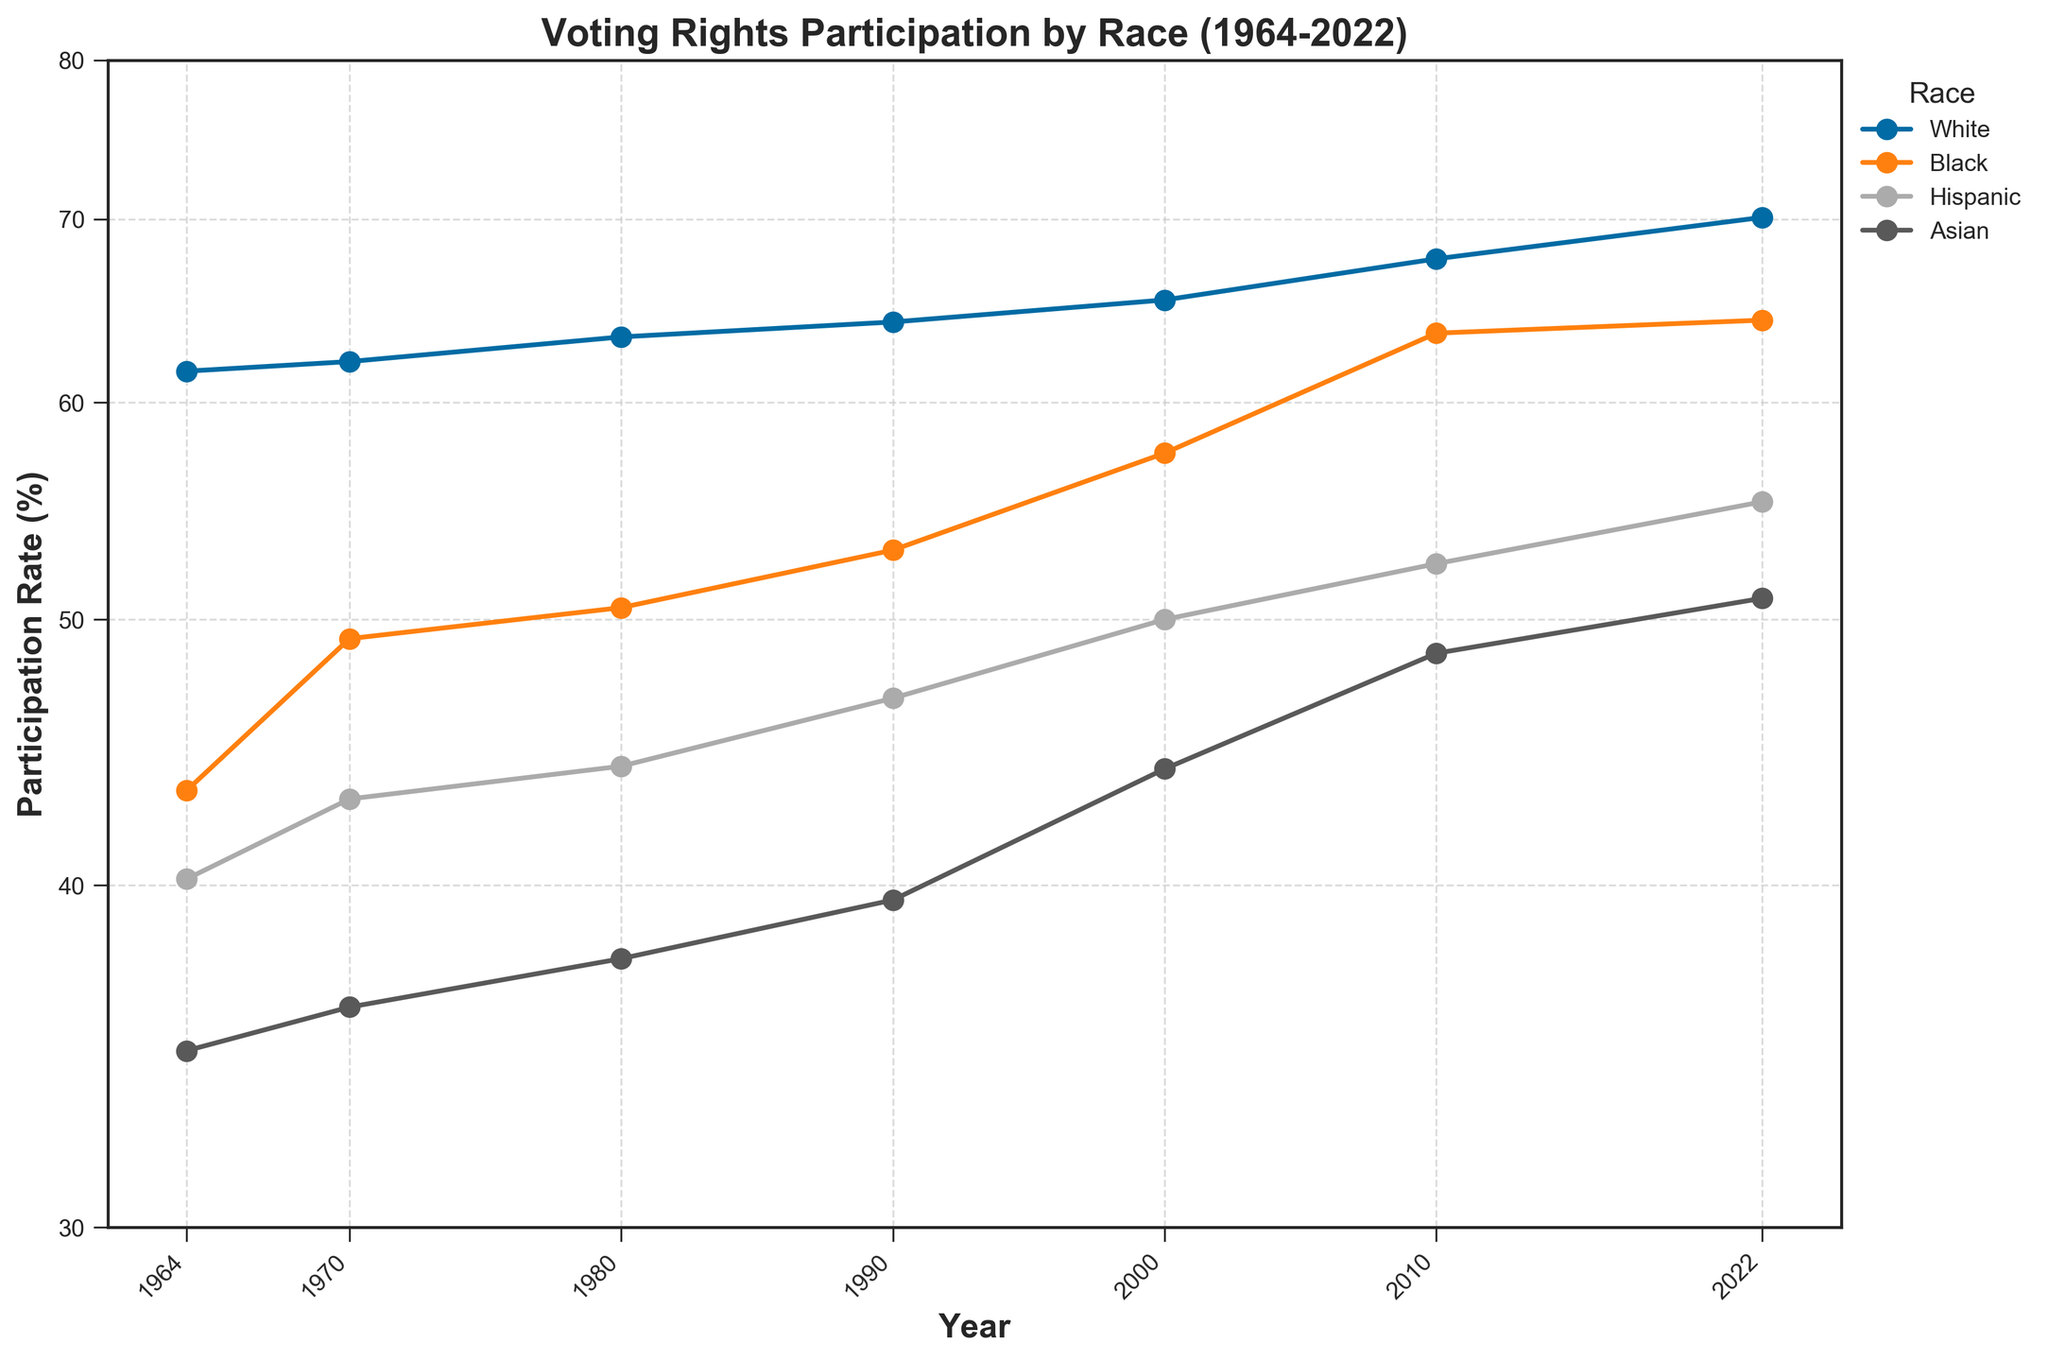What's the title of the figure? The title of the figure is displayed on top of the plot.
Answer: Voting Rights Participation by Race (1964-2022) What does the x-axis represent? The x-axis label shows which variable is represented along the horizontal axis.
Answer: Year What is the y-axis range? To understand the range, look at the minimum and maximum values on the y-axis.
Answer: 30 to 80 Which race had the lowest participation rate in 1964? By looking at the participation rates for each race in 1964, the lowest value determines the answer.
Answer: Asian What year shows the maximum participation rate for Black voters? By examining the plot for the highest point on the 'Black' curve, we identify the corresponding year on the x-axis.
Answer: 2022 Compare the participation rate of Black voters in 1964 to that in 2010. Identify the points for Black voters in 1964 and 2010 and compare their values on the y-axis.
Answer: It increased from 43.3% to 63.6% Which race had the most significant increase in participation rate from 1964 to 2022? Subtract the 1964 participation rate for each race from their 2022 rate and compare the increases to find the largest difference.
Answer: Black How many data points are there for Asian voters? Count the number of markers for the Asian race on the plot.
Answer: 7 What is the average participation rate for Hispanic voters over the years shown? Add up all participation rates for Hispanic voters and divide by the number of data points. Since there are values in 7 years, the sum is: 40.2 + 43.0 + 44.2 + 46.8 + 50.0 + 52.4 + 55.2 = 331.8, so 331.8 / 7 = 47.4.
Answer: 47.4 Between which consecutive years did the participation rate for White voters increase the most? Calculate the difference between consecutive years for White voters and identify the maximum increase. The differences are 0.5 (1964-1970), 1.3 (1970-1980), 0.8 (1980-1990), 1.2 (1990-2000), 2.3 (2000-2010), 2.4 (2010-2022). The largest increase is 2.4 from 2010 to 2022.
Answer: 2010 to 2022 